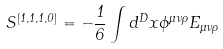<formula> <loc_0><loc_0><loc_500><loc_500>S ^ { [ 1 , 1 , 1 , 0 ] } = - \frac { 1 } { 6 } \int d ^ { D } x \phi ^ { \mu \nu \rho } E _ { \mu \nu \rho }</formula> 